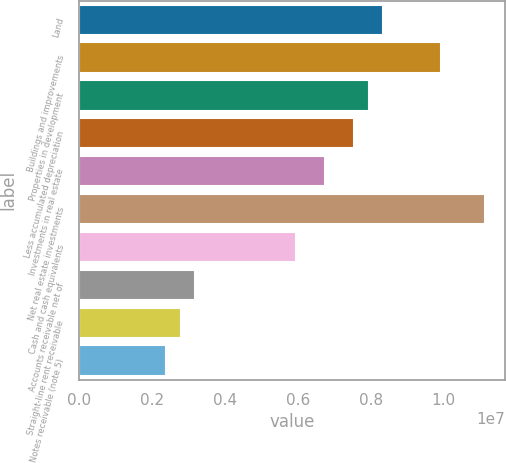Convert chart. <chart><loc_0><loc_0><loc_500><loc_500><bar_chart><fcel>Land<fcel>Buildings and improvements<fcel>Properties in development<fcel>Less accumulated depreciation<fcel>Investments in real estate<fcel>Net real estate investments<fcel>Cash and cash equivalents<fcel>Accounts receivable net of<fcel>Straight-line rent receivable<fcel>Notes receivable (note 5)<nl><fcel>8.3441e+06<fcel>9.93329e+06<fcel>7.9468e+06<fcel>7.5495e+06<fcel>6.7549e+06<fcel>1.11252e+07<fcel>5.9603e+06<fcel>3.17921e+06<fcel>2.78191e+06<fcel>2.38461e+06<nl></chart> 